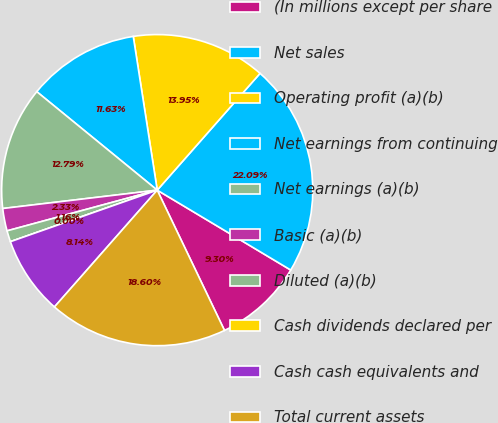Convert chart to OTSL. <chart><loc_0><loc_0><loc_500><loc_500><pie_chart><fcel>(In millions except per share<fcel>Net sales<fcel>Operating profit (a)(b)<fcel>Net earnings from continuing<fcel>Net earnings (a)(b)<fcel>Basic (a)(b)<fcel>Diluted (a)(b)<fcel>Cash dividends declared per<fcel>Cash cash equivalents and<fcel>Total current assets<nl><fcel>9.3%<fcel>22.09%<fcel>13.95%<fcel>11.63%<fcel>12.79%<fcel>2.33%<fcel>1.16%<fcel>0.0%<fcel>8.14%<fcel>18.6%<nl></chart> 